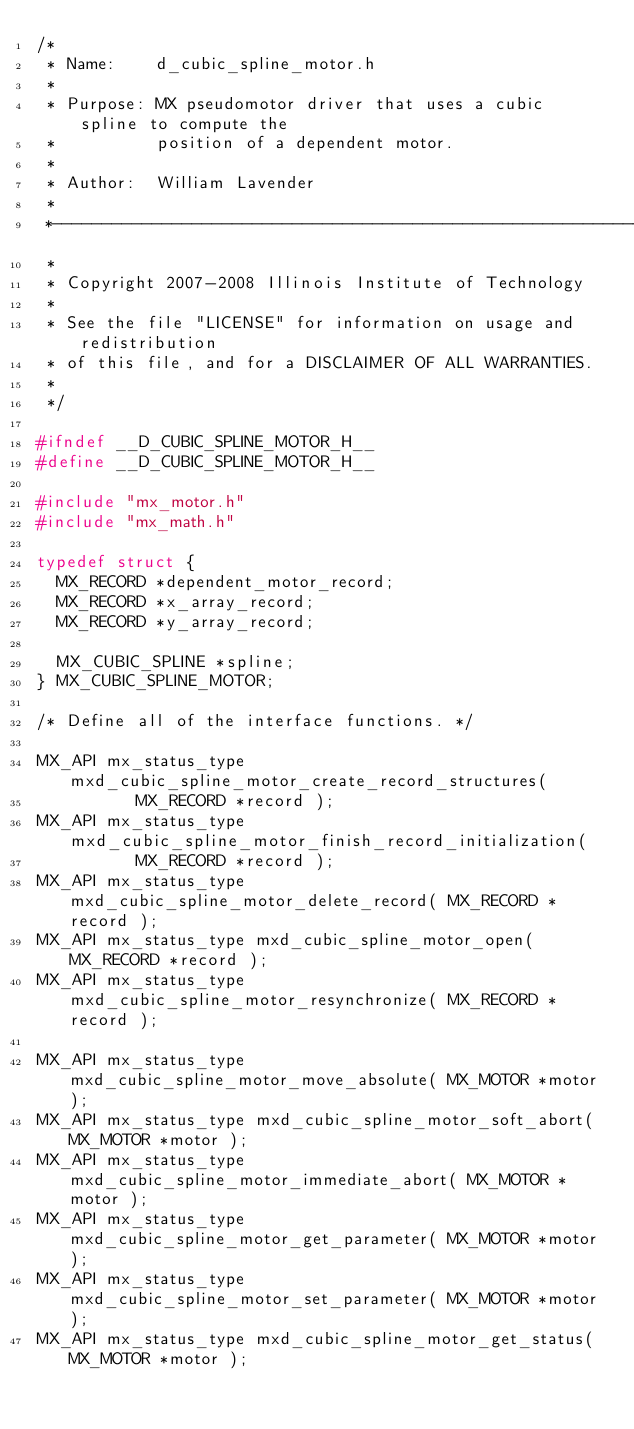Convert code to text. <code><loc_0><loc_0><loc_500><loc_500><_C_>/*
 * Name:    d_cubic_spline_motor.h 
 *
 * Purpose: MX pseudomotor driver that uses a cubic spline to compute the
 *          position of a dependent motor.
 *
 * Author:  William Lavender
 *
 *--------------------------------------------------------------------------
 *
 * Copyright 2007-2008 Illinois Institute of Technology
 *
 * See the file "LICENSE" for information on usage and redistribution
 * of this file, and for a DISCLAIMER OF ALL WARRANTIES.
 *
 */

#ifndef __D_CUBIC_SPLINE_MOTOR_H__
#define __D_CUBIC_SPLINE_MOTOR_H__

#include "mx_motor.h"
#include "mx_math.h"

typedef struct {
	MX_RECORD *dependent_motor_record;
	MX_RECORD *x_array_record;
	MX_RECORD *y_array_record;

	MX_CUBIC_SPLINE *spline;
} MX_CUBIC_SPLINE_MOTOR;

/* Define all of the interface functions. */

MX_API mx_status_type mxd_cubic_spline_motor_create_record_structures(
					MX_RECORD *record );
MX_API mx_status_type mxd_cubic_spline_motor_finish_record_initialization(
					MX_RECORD *record );
MX_API mx_status_type mxd_cubic_spline_motor_delete_record( MX_RECORD *record );
MX_API mx_status_type mxd_cubic_spline_motor_open( MX_RECORD *record );
MX_API mx_status_type mxd_cubic_spline_motor_resynchronize( MX_RECORD *record );

MX_API mx_status_type mxd_cubic_spline_motor_move_absolute( MX_MOTOR *motor );
MX_API mx_status_type mxd_cubic_spline_motor_soft_abort( MX_MOTOR *motor );
MX_API mx_status_type mxd_cubic_spline_motor_immediate_abort( MX_MOTOR *motor );
MX_API mx_status_type mxd_cubic_spline_motor_get_parameter( MX_MOTOR *motor );
MX_API mx_status_type mxd_cubic_spline_motor_set_parameter( MX_MOTOR *motor );
MX_API mx_status_type mxd_cubic_spline_motor_get_status( MX_MOTOR *motor );</code> 